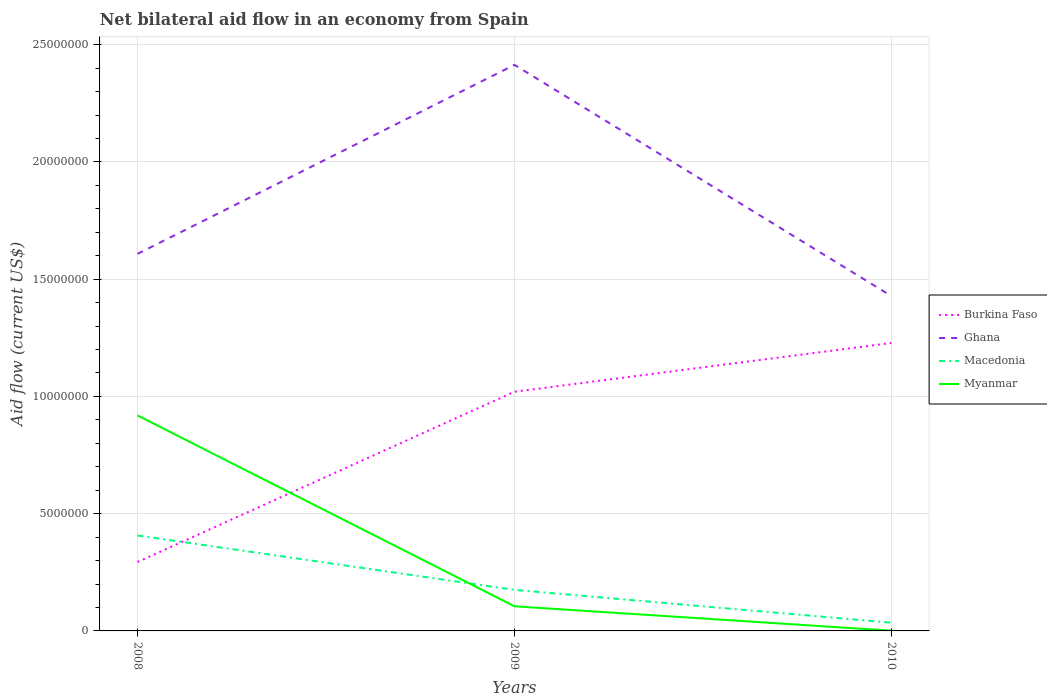How many different coloured lines are there?
Your answer should be very brief. 4. Does the line corresponding to Ghana intersect with the line corresponding to Myanmar?
Offer a very short reply. No. In which year was the net bilateral aid flow in Macedonia maximum?
Provide a succinct answer. 2010. What is the total net bilateral aid flow in Ghana in the graph?
Give a very brief answer. 9.86e+06. What is the difference between the highest and the second highest net bilateral aid flow in Burkina Faso?
Offer a terse response. 9.34e+06. How many lines are there?
Provide a short and direct response. 4. Where does the legend appear in the graph?
Provide a short and direct response. Center right. How are the legend labels stacked?
Provide a succinct answer. Vertical. What is the title of the graph?
Give a very brief answer. Net bilateral aid flow in an economy from Spain. Does "Aruba" appear as one of the legend labels in the graph?
Your answer should be very brief. No. What is the Aid flow (current US$) of Burkina Faso in 2008?
Make the answer very short. 2.94e+06. What is the Aid flow (current US$) in Ghana in 2008?
Your answer should be compact. 1.61e+07. What is the Aid flow (current US$) of Macedonia in 2008?
Offer a very short reply. 4.07e+06. What is the Aid flow (current US$) in Myanmar in 2008?
Ensure brevity in your answer.  9.19e+06. What is the Aid flow (current US$) of Burkina Faso in 2009?
Provide a short and direct response. 1.02e+07. What is the Aid flow (current US$) of Ghana in 2009?
Offer a very short reply. 2.41e+07. What is the Aid flow (current US$) of Macedonia in 2009?
Give a very brief answer. 1.75e+06. What is the Aid flow (current US$) of Myanmar in 2009?
Offer a terse response. 1.05e+06. What is the Aid flow (current US$) of Burkina Faso in 2010?
Your answer should be very brief. 1.23e+07. What is the Aid flow (current US$) in Ghana in 2010?
Offer a very short reply. 1.43e+07. Across all years, what is the maximum Aid flow (current US$) in Burkina Faso?
Ensure brevity in your answer.  1.23e+07. Across all years, what is the maximum Aid flow (current US$) of Ghana?
Give a very brief answer. 2.41e+07. Across all years, what is the maximum Aid flow (current US$) in Macedonia?
Make the answer very short. 4.07e+06. Across all years, what is the maximum Aid flow (current US$) of Myanmar?
Offer a terse response. 9.19e+06. Across all years, what is the minimum Aid flow (current US$) of Burkina Faso?
Your response must be concise. 2.94e+06. Across all years, what is the minimum Aid flow (current US$) in Ghana?
Offer a very short reply. 1.43e+07. Across all years, what is the minimum Aid flow (current US$) in Macedonia?
Keep it short and to the point. 3.50e+05. What is the total Aid flow (current US$) of Burkina Faso in the graph?
Ensure brevity in your answer.  2.54e+07. What is the total Aid flow (current US$) of Ghana in the graph?
Offer a very short reply. 5.45e+07. What is the total Aid flow (current US$) of Macedonia in the graph?
Provide a succinct answer. 6.17e+06. What is the total Aid flow (current US$) of Myanmar in the graph?
Provide a short and direct response. 1.02e+07. What is the difference between the Aid flow (current US$) of Burkina Faso in 2008 and that in 2009?
Provide a short and direct response. -7.26e+06. What is the difference between the Aid flow (current US$) of Ghana in 2008 and that in 2009?
Provide a short and direct response. -8.06e+06. What is the difference between the Aid flow (current US$) in Macedonia in 2008 and that in 2009?
Provide a succinct answer. 2.32e+06. What is the difference between the Aid flow (current US$) of Myanmar in 2008 and that in 2009?
Provide a succinct answer. 8.14e+06. What is the difference between the Aid flow (current US$) in Burkina Faso in 2008 and that in 2010?
Offer a very short reply. -9.34e+06. What is the difference between the Aid flow (current US$) in Ghana in 2008 and that in 2010?
Your answer should be very brief. 1.80e+06. What is the difference between the Aid flow (current US$) of Macedonia in 2008 and that in 2010?
Keep it short and to the point. 3.72e+06. What is the difference between the Aid flow (current US$) of Myanmar in 2008 and that in 2010?
Make the answer very short. 9.18e+06. What is the difference between the Aid flow (current US$) of Burkina Faso in 2009 and that in 2010?
Give a very brief answer. -2.08e+06. What is the difference between the Aid flow (current US$) of Ghana in 2009 and that in 2010?
Keep it short and to the point. 9.86e+06. What is the difference between the Aid flow (current US$) of Macedonia in 2009 and that in 2010?
Ensure brevity in your answer.  1.40e+06. What is the difference between the Aid flow (current US$) of Myanmar in 2009 and that in 2010?
Your answer should be very brief. 1.04e+06. What is the difference between the Aid flow (current US$) of Burkina Faso in 2008 and the Aid flow (current US$) of Ghana in 2009?
Your answer should be very brief. -2.12e+07. What is the difference between the Aid flow (current US$) in Burkina Faso in 2008 and the Aid flow (current US$) in Macedonia in 2009?
Offer a terse response. 1.19e+06. What is the difference between the Aid flow (current US$) in Burkina Faso in 2008 and the Aid flow (current US$) in Myanmar in 2009?
Provide a short and direct response. 1.89e+06. What is the difference between the Aid flow (current US$) in Ghana in 2008 and the Aid flow (current US$) in Macedonia in 2009?
Offer a terse response. 1.43e+07. What is the difference between the Aid flow (current US$) in Ghana in 2008 and the Aid flow (current US$) in Myanmar in 2009?
Ensure brevity in your answer.  1.50e+07. What is the difference between the Aid flow (current US$) in Macedonia in 2008 and the Aid flow (current US$) in Myanmar in 2009?
Your answer should be very brief. 3.02e+06. What is the difference between the Aid flow (current US$) of Burkina Faso in 2008 and the Aid flow (current US$) of Ghana in 2010?
Your answer should be compact. -1.13e+07. What is the difference between the Aid flow (current US$) in Burkina Faso in 2008 and the Aid flow (current US$) in Macedonia in 2010?
Offer a terse response. 2.59e+06. What is the difference between the Aid flow (current US$) of Burkina Faso in 2008 and the Aid flow (current US$) of Myanmar in 2010?
Provide a short and direct response. 2.93e+06. What is the difference between the Aid flow (current US$) in Ghana in 2008 and the Aid flow (current US$) in Macedonia in 2010?
Provide a short and direct response. 1.57e+07. What is the difference between the Aid flow (current US$) in Ghana in 2008 and the Aid flow (current US$) in Myanmar in 2010?
Your answer should be compact. 1.61e+07. What is the difference between the Aid flow (current US$) in Macedonia in 2008 and the Aid flow (current US$) in Myanmar in 2010?
Make the answer very short. 4.06e+06. What is the difference between the Aid flow (current US$) of Burkina Faso in 2009 and the Aid flow (current US$) of Ghana in 2010?
Provide a short and direct response. -4.08e+06. What is the difference between the Aid flow (current US$) in Burkina Faso in 2009 and the Aid flow (current US$) in Macedonia in 2010?
Offer a very short reply. 9.85e+06. What is the difference between the Aid flow (current US$) of Burkina Faso in 2009 and the Aid flow (current US$) of Myanmar in 2010?
Ensure brevity in your answer.  1.02e+07. What is the difference between the Aid flow (current US$) of Ghana in 2009 and the Aid flow (current US$) of Macedonia in 2010?
Ensure brevity in your answer.  2.38e+07. What is the difference between the Aid flow (current US$) in Ghana in 2009 and the Aid flow (current US$) in Myanmar in 2010?
Keep it short and to the point. 2.41e+07. What is the difference between the Aid flow (current US$) in Macedonia in 2009 and the Aid flow (current US$) in Myanmar in 2010?
Your answer should be very brief. 1.74e+06. What is the average Aid flow (current US$) of Burkina Faso per year?
Your response must be concise. 8.47e+06. What is the average Aid flow (current US$) in Ghana per year?
Keep it short and to the point. 1.82e+07. What is the average Aid flow (current US$) of Macedonia per year?
Provide a succinct answer. 2.06e+06. What is the average Aid flow (current US$) in Myanmar per year?
Your answer should be very brief. 3.42e+06. In the year 2008, what is the difference between the Aid flow (current US$) in Burkina Faso and Aid flow (current US$) in Ghana?
Offer a terse response. -1.31e+07. In the year 2008, what is the difference between the Aid flow (current US$) of Burkina Faso and Aid flow (current US$) of Macedonia?
Offer a terse response. -1.13e+06. In the year 2008, what is the difference between the Aid flow (current US$) in Burkina Faso and Aid flow (current US$) in Myanmar?
Your response must be concise. -6.25e+06. In the year 2008, what is the difference between the Aid flow (current US$) in Ghana and Aid flow (current US$) in Macedonia?
Make the answer very short. 1.20e+07. In the year 2008, what is the difference between the Aid flow (current US$) in Ghana and Aid flow (current US$) in Myanmar?
Keep it short and to the point. 6.89e+06. In the year 2008, what is the difference between the Aid flow (current US$) of Macedonia and Aid flow (current US$) of Myanmar?
Keep it short and to the point. -5.12e+06. In the year 2009, what is the difference between the Aid flow (current US$) in Burkina Faso and Aid flow (current US$) in Ghana?
Provide a short and direct response. -1.39e+07. In the year 2009, what is the difference between the Aid flow (current US$) in Burkina Faso and Aid flow (current US$) in Macedonia?
Provide a short and direct response. 8.45e+06. In the year 2009, what is the difference between the Aid flow (current US$) of Burkina Faso and Aid flow (current US$) of Myanmar?
Keep it short and to the point. 9.15e+06. In the year 2009, what is the difference between the Aid flow (current US$) of Ghana and Aid flow (current US$) of Macedonia?
Your answer should be very brief. 2.24e+07. In the year 2009, what is the difference between the Aid flow (current US$) in Ghana and Aid flow (current US$) in Myanmar?
Give a very brief answer. 2.31e+07. In the year 2009, what is the difference between the Aid flow (current US$) of Macedonia and Aid flow (current US$) of Myanmar?
Your answer should be compact. 7.00e+05. In the year 2010, what is the difference between the Aid flow (current US$) in Burkina Faso and Aid flow (current US$) in Macedonia?
Offer a very short reply. 1.19e+07. In the year 2010, what is the difference between the Aid flow (current US$) in Burkina Faso and Aid flow (current US$) in Myanmar?
Ensure brevity in your answer.  1.23e+07. In the year 2010, what is the difference between the Aid flow (current US$) of Ghana and Aid flow (current US$) of Macedonia?
Offer a terse response. 1.39e+07. In the year 2010, what is the difference between the Aid flow (current US$) of Ghana and Aid flow (current US$) of Myanmar?
Your response must be concise. 1.43e+07. In the year 2010, what is the difference between the Aid flow (current US$) of Macedonia and Aid flow (current US$) of Myanmar?
Your response must be concise. 3.40e+05. What is the ratio of the Aid flow (current US$) in Burkina Faso in 2008 to that in 2009?
Your answer should be very brief. 0.29. What is the ratio of the Aid flow (current US$) in Ghana in 2008 to that in 2009?
Provide a short and direct response. 0.67. What is the ratio of the Aid flow (current US$) of Macedonia in 2008 to that in 2009?
Make the answer very short. 2.33. What is the ratio of the Aid flow (current US$) of Myanmar in 2008 to that in 2009?
Your response must be concise. 8.75. What is the ratio of the Aid flow (current US$) of Burkina Faso in 2008 to that in 2010?
Your response must be concise. 0.24. What is the ratio of the Aid flow (current US$) in Ghana in 2008 to that in 2010?
Your response must be concise. 1.13. What is the ratio of the Aid flow (current US$) of Macedonia in 2008 to that in 2010?
Your answer should be very brief. 11.63. What is the ratio of the Aid flow (current US$) of Myanmar in 2008 to that in 2010?
Ensure brevity in your answer.  919. What is the ratio of the Aid flow (current US$) in Burkina Faso in 2009 to that in 2010?
Keep it short and to the point. 0.83. What is the ratio of the Aid flow (current US$) of Ghana in 2009 to that in 2010?
Give a very brief answer. 1.69. What is the ratio of the Aid flow (current US$) in Macedonia in 2009 to that in 2010?
Give a very brief answer. 5. What is the ratio of the Aid flow (current US$) in Myanmar in 2009 to that in 2010?
Your answer should be very brief. 105. What is the difference between the highest and the second highest Aid flow (current US$) of Burkina Faso?
Give a very brief answer. 2.08e+06. What is the difference between the highest and the second highest Aid flow (current US$) of Ghana?
Your response must be concise. 8.06e+06. What is the difference between the highest and the second highest Aid flow (current US$) of Macedonia?
Offer a terse response. 2.32e+06. What is the difference between the highest and the second highest Aid flow (current US$) in Myanmar?
Offer a very short reply. 8.14e+06. What is the difference between the highest and the lowest Aid flow (current US$) in Burkina Faso?
Ensure brevity in your answer.  9.34e+06. What is the difference between the highest and the lowest Aid flow (current US$) of Ghana?
Provide a succinct answer. 9.86e+06. What is the difference between the highest and the lowest Aid flow (current US$) in Macedonia?
Make the answer very short. 3.72e+06. What is the difference between the highest and the lowest Aid flow (current US$) in Myanmar?
Offer a very short reply. 9.18e+06. 